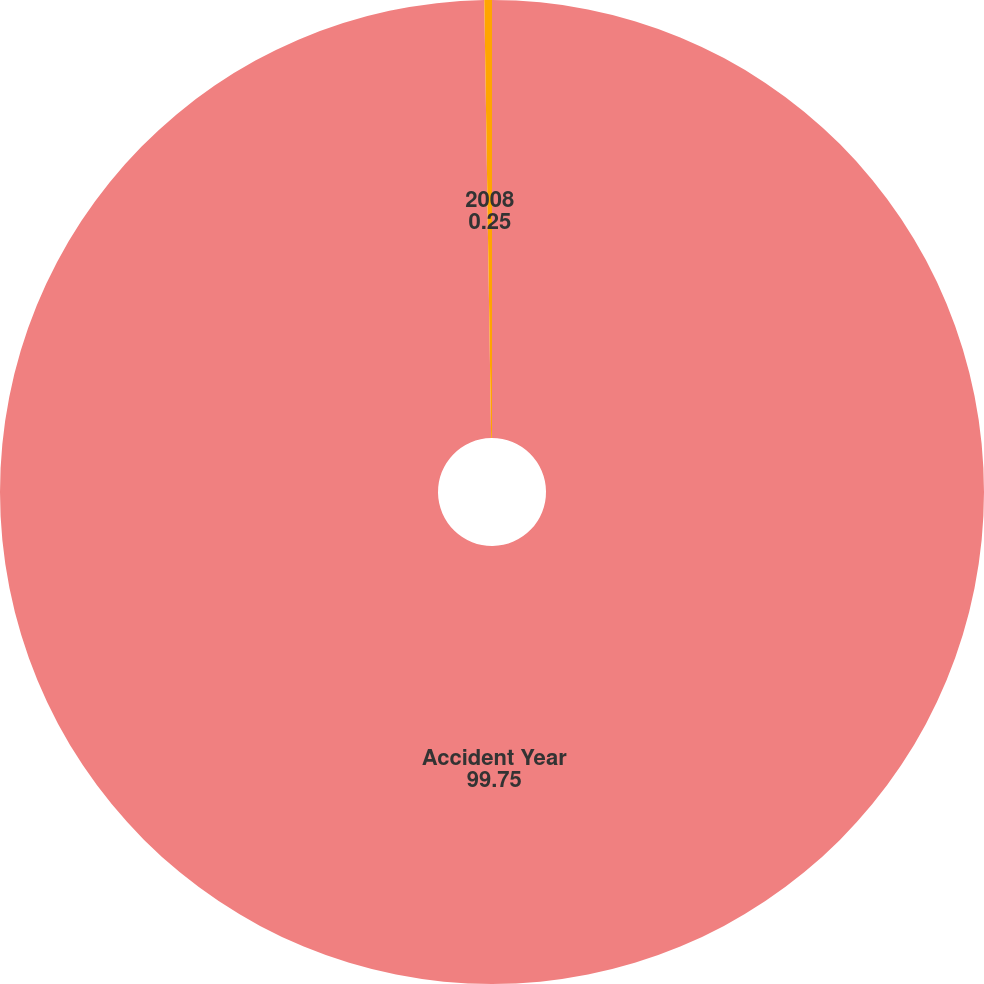Convert chart. <chart><loc_0><loc_0><loc_500><loc_500><pie_chart><fcel>Accident Year<fcel>2008<nl><fcel>99.75%<fcel>0.25%<nl></chart> 